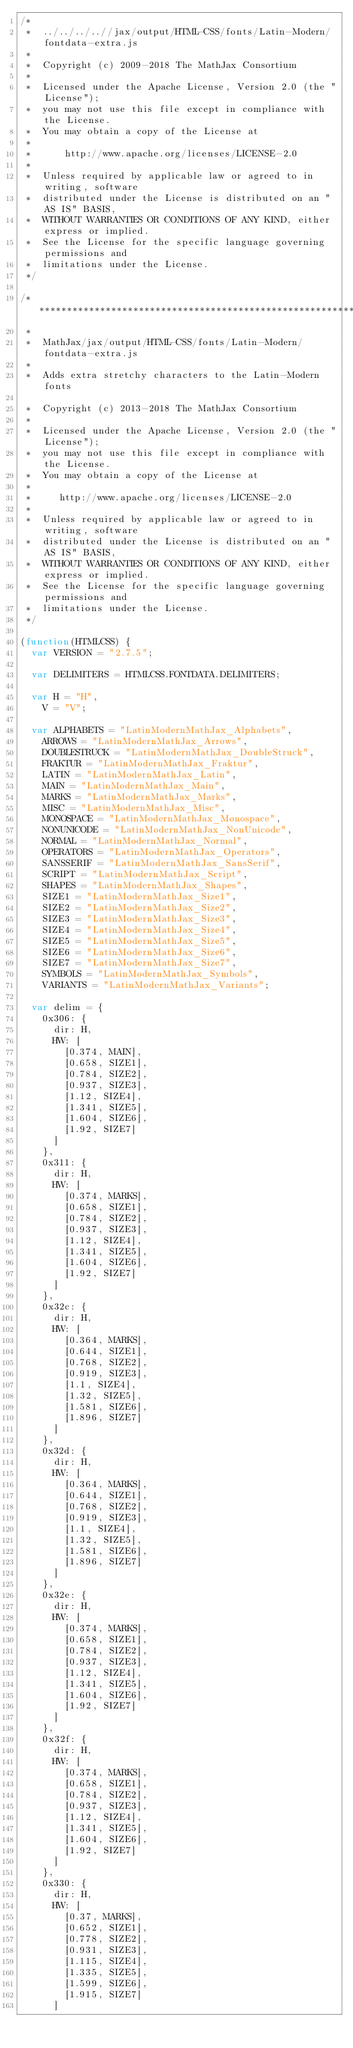<code> <loc_0><loc_0><loc_500><loc_500><_JavaScript_>/*
 *  ../../../..//jax/output/HTML-CSS/fonts/Latin-Modern/fontdata-extra.js
 *
 *  Copyright (c) 2009-2018 The MathJax Consortium
 *
 *  Licensed under the Apache License, Version 2.0 (the "License");
 *  you may not use this file except in compliance with the License.
 *  You may obtain a copy of the License at
 *
 *      http://www.apache.org/licenses/LICENSE-2.0
 *
 *  Unless required by applicable law or agreed to in writing, software
 *  distributed under the License is distributed on an "AS IS" BASIS,
 *  WITHOUT WARRANTIES OR CONDITIONS OF ANY KIND, either express or implied.
 *  See the License for the specific language governing permissions and
 *  limitations under the License.
 */

/*************************************************************
 *
 *  MathJax/jax/output/HTML-CSS/fonts/Latin-Modern/fontdata-extra.js
 *  
 *  Adds extra stretchy characters to the Latin-Modern fonts

 *  Copyright (c) 2013-2018 The MathJax Consortium
 *
 *  Licensed under the Apache License, Version 2.0 (the "License");
 *  you may not use this file except in compliance with the License.
 *  You may obtain a copy of the License at
 *
 *     http://www.apache.org/licenses/LICENSE-2.0
 *
 *  Unless required by applicable law or agreed to in writing, software
 *  distributed under the License is distributed on an "AS IS" BASIS,
 *  WITHOUT WARRANTIES OR CONDITIONS OF ANY KIND, either express or implied.
 *  See the License for the specific language governing permissions and
 *  limitations under the License.
 */

(function(HTMLCSS) {
  var VERSION = "2.7.5";

  var DELIMITERS = HTMLCSS.FONTDATA.DELIMITERS;

  var H = "H",
    V = "V";

  var ALPHABETS = "LatinModernMathJax_Alphabets",
    ARROWS = "LatinModernMathJax_Arrows",
    DOUBLESTRUCK = "LatinModernMathJax_DoubleStruck",
    FRAKTUR = "LatinModernMathJax_Fraktur",
    LATIN = "LatinModernMathJax_Latin",
    MAIN = "LatinModernMathJax_Main",
    MARKS = "LatinModernMathJax_Marks",
    MISC = "LatinModernMathJax_Misc",
    MONOSPACE = "LatinModernMathJax_Monospace",
    NONUNICODE = "LatinModernMathJax_NonUnicode",
    NORMAL = "LatinModernMathJax_Normal",
    OPERATORS = "LatinModernMathJax_Operators",
    SANSSERIF = "LatinModernMathJax_SansSerif",
    SCRIPT = "LatinModernMathJax_Script",
    SHAPES = "LatinModernMathJax_Shapes",
    SIZE1 = "LatinModernMathJax_Size1",
    SIZE2 = "LatinModernMathJax_Size2",
    SIZE3 = "LatinModernMathJax_Size3",
    SIZE4 = "LatinModernMathJax_Size4",
    SIZE5 = "LatinModernMathJax_Size5",
    SIZE6 = "LatinModernMathJax_Size6",
    SIZE7 = "LatinModernMathJax_Size7",
    SYMBOLS = "LatinModernMathJax_Symbols",
    VARIANTS = "LatinModernMathJax_Variants";

  var delim = {
    0x306: {
      dir: H,
      HW: [
        [0.374, MAIN],
        [0.658, SIZE1],
        [0.784, SIZE2],
        [0.937, SIZE3],
        [1.12, SIZE4],
        [1.341, SIZE5],
        [1.604, SIZE6],
        [1.92, SIZE7]
      ]
    },
    0x311: {
      dir: H,
      HW: [
        [0.374, MARKS],
        [0.658, SIZE1],
        [0.784, SIZE2],
        [0.937, SIZE3],
        [1.12, SIZE4],
        [1.341, SIZE5],
        [1.604, SIZE6],
        [1.92, SIZE7]
      ]
    },
    0x32c: {
      dir: H,
      HW: [
        [0.364, MARKS],
        [0.644, SIZE1],
        [0.768, SIZE2],
        [0.919, SIZE3],
        [1.1, SIZE4],
        [1.32, SIZE5],
        [1.581, SIZE6],
        [1.896, SIZE7]
      ]
    },
    0x32d: {
      dir: H,
      HW: [
        [0.364, MARKS],
        [0.644, SIZE1],
        [0.768, SIZE2],
        [0.919, SIZE3],
        [1.1, SIZE4],
        [1.32, SIZE5],
        [1.581, SIZE6],
        [1.896, SIZE7]
      ]
    },
    0x32e: {
      dir: H,
      HW: [
        [0.374, MARKS],
        [0.658, SIZE1],
        [0.784, SIZE2],
        [0.937, SIZE3],
        [1.12, SIZE4],
        [1.341, SIZE5],
        [1.604, SIZE6],
        [1.92, SIZE7]
      ]
    },
    0x32f: {
      dir: H,
      HW: [
        [0.374, MARKS],
        [0.658, SIZE1],
        [0.784, SIZE2],
        [0.937, SIZE3],
        [1.12, SIZE4],
        [1.341, SIZE5],
        [1.604, SIZE6],
        [1.92, SIZE7]
      ]
    },
    0x330: {
      dir: H,
      HW: [
        [0.37, MARKS],
        [0.652, SIZE1],
        [0.778, SIZE2],
        [0.931, SIZE3],
        [1.115, SIZE4],
        [1.335, SIZE5],
        [1.599, SIZE6],
        [1.915, SIZE7]
      ]</code> 